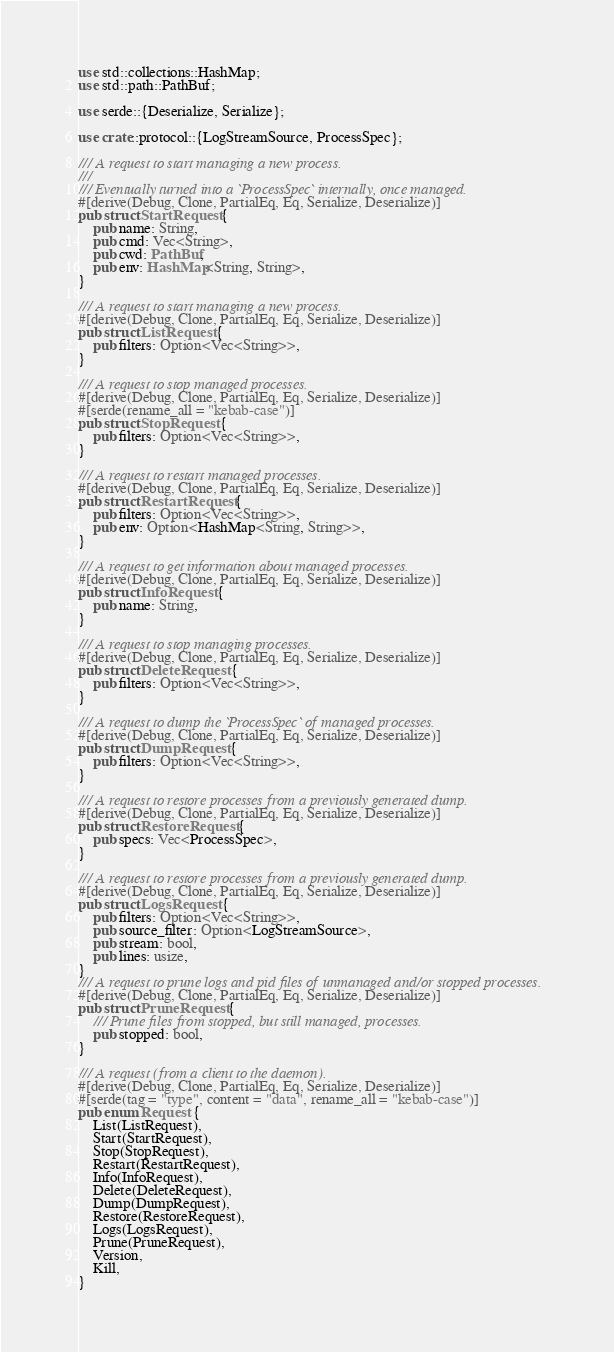Convert code to text. <code><loc_0><loc_0><loc_500><loc_500><_Rust_>use std::collections::HashMap;
use std::path::PathBuf;

use serde::{Deserialize, Serialize};

use crate::protocol::{LogStreamSource, ProcessSpec};

/// A request to start managing a new process.
///
/// Eventually turned into a `ProcessSpec` internally, once managed.
#[derive(Debug, Clone, PartialEq, Eq, Serialize, Deserialize)]
pub struct StartRequest {
    pub name: String,
    pub cmd: Vec<String>,
    pub cwd: PathBuf,
    pub env: HashMap<String, String>,
}

/// A request to start managing a new process.
#[derive(Debug, Clone, PartialEq, Eq, Serialize, Deserialize)]
pub struct ListRequest {
    pub filters: Option<Vec<String>>,
}

/// A request to stop managed processes.
#[derive(Debug, Clone, PartialEq, Eq, Serialize, Deserialize)]
#[serde(rename_all = "kebab-case")]
pub struct StopRequest {
    pub filters: Option<Vec<String>>,
}

/// A request to restart managed processes.
#[derive(Debug, Clone, PartialEq, Eq, Serialize, Deserialize)]
pub struct RestartRequest {
    pub filters: Option<Vec<String>>,
    pub env: Option<HashMap<String, String>>,
}

/// A request to get information about managed processes.
#[derive(Debug, Clone, PartialEq, Eq, Serialize, Deserialize)]
pub struct InfoRequest {
    pub name: String,
}

/// A request to stop managing processes.
#[derive(Debug, Clone, PartialEq, Eq, Serialize, Deserialize)]
pub struct DeleteRequest {
    pub filters: Option<Vec<String>>,
}

/// A request to dump the `ProcessSpec` of managed processes.
#[derive(Debug, Clone, PartialEq, Eq, Serialize, Deserialize)]
pub struct DumpRequest {
    pub filters: Option<Vec<String>>,
}

/// A request to restore processes from a previously generated dump.
#[derive(Debug, Clone, PartialEq, Eq, Serialize, Deserialize)]
pub struct RestoreRequest {
    pub specs: Vec<ProcessSpec>,
}

/// A request to restore processes from a previously generated dump.
#[derive(Debug, Clone, PartialEq, Eq, Serialize, Deserialize)]
pub struct LogsRequest {
    pub filters: Option<Vec<String>>,
    pub source_filter: Option<LogStreamSource>,
    pub stream: bool,
    pub lines: usize,
}
/// A request to prune logs and pid files of unmanaged and/or stopped processes.
#[derive(Debug, Clone, PartialEq, Eq, Serialize, Deserialize)]
pub struct PruneRequest {
    /// Prune files from stopped, but still managed, processes.
    pub stopped: bool,
}

/// A request (from a client to the daemon).
#[derive(Debug, Clone, PartialEq, Eq, Serialize, Deserialize)]
#[serde(tag = "type", content = "data", rename_all = "kebab-case")]
pub enum Request {
    List(ListRequest),
    Start(StartRequest),
    Stop(StopRequest),
    Restart(RestartRequest),
    Info(InfoRequest),
    Delete(DeleteRequest),
    Dump(DumpRequest),
    Restore(RestoreRequest),
    Logs(LogsRequest),
    Prune(PruneRequest),
    Version,
    Kill,
}
</code> 